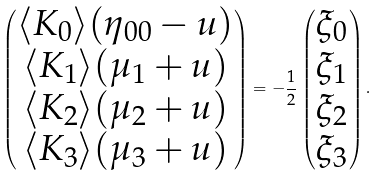Convert formula to latex. <formula><loc_0><loc_0><loc_500><loc_500>\begin{pmatrix} \langle K _ { 0 } \rangle ( \eta _ { 0 0 } - u ) \\ \langle K _ { 1 } \rangle ( \mu _ { 1 } + u ) \\ \langle K _ { 2 } \rangle ( \mu _ { 2 } + u ) \\ \langle K _ { 3 } \rangle ( \mu _ { 3 } + u ) \end{pmatrix} = - \frac { 1 } { 2 } \begin{pmatrix} \xi _ { 0 } \\ \xi _ { 1 } \\ \xi _ { 2 } \\ \xi _ { 3 } \\ \end{pmatrix} .</formula> 